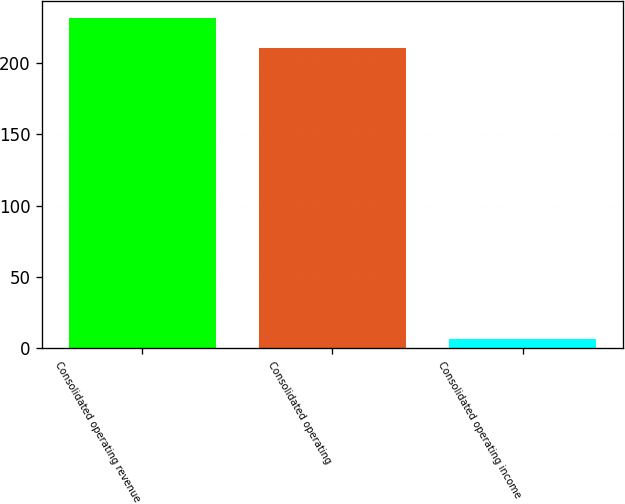Convert chart. <chart><loc_0><loc_0><loc_500><loc_500><bar_chart><fcel>Consolidated operating revenue<fcel>Consolidated operating<fcel>Consolidated operating income<nl><fcel>231.77<fcel>210.7<fcel>6.6<nl></chart> 